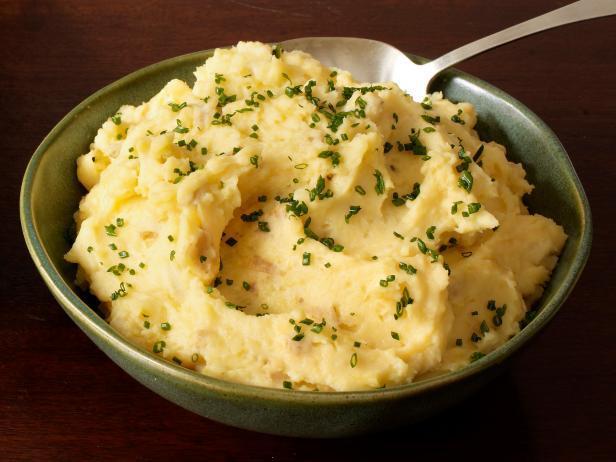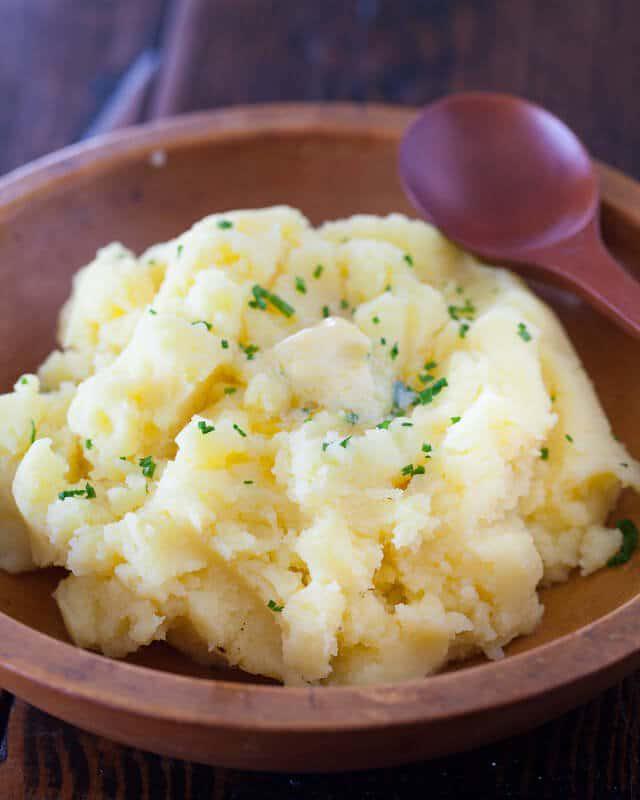The first image is the image on the left, the second image is the image on the right. For the images displayed, is the sentence "The right image includes a round brown bowl with mashed potatoes in it and a spoon." factually correct? Answer yes or no. Yes. The first image is the image on the left, the second image is the image on the right. Given the left and right images, does the statement "The left and right image contains a total of two colored mashed potato bowls." hold true? Answer yes or no. Yes. 